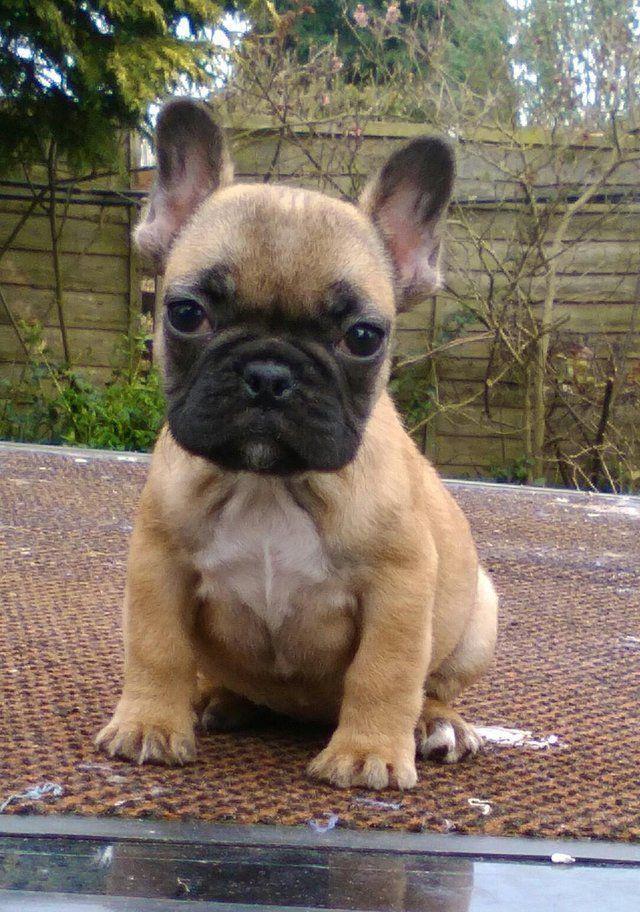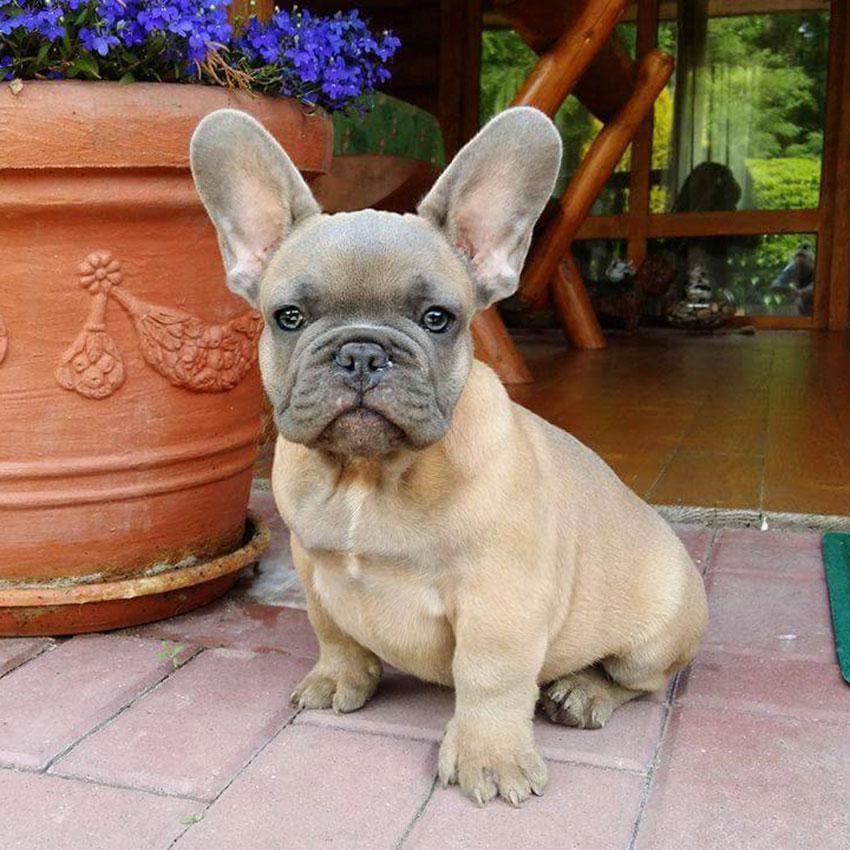The first image is the image on the left, the second image is the image on the right. For the images displayed, is the sentence "There are no more than five dogs" factually correct? Answer yes or no. Yes. The first image is the image on the left, the second image is the image on the right. Analyze the images presented: Is the assertion "An image shows a row of at least 8 dogs on a cement step." valid? Answer yes or no. No. 